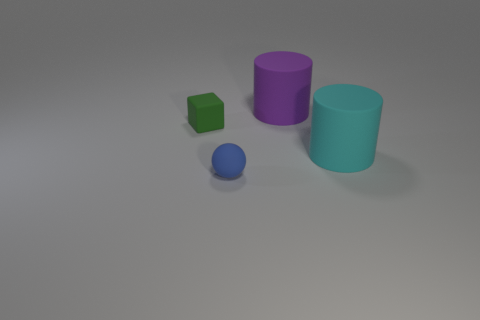There is a large rubber thing that is to the right of the rubber cylinder that is behind the matte cylinder that is on the right side of the purple thing; what is its shape?
Make the answer very short. Cylinder. There is a large matte cylinder in front of the big purple rubber object; is it the same color as the large rubber object on the left side of the big cyan cylinder?
Give a very brief answer. No. Are there any other things that are the same size as the blue matte sphere?
Your response must be concise. Yes. Are there any balls in front of the tiny sphere?
Provide a succinct answer. No. What number of cyan matte things are the same shape as the green matte thing?
Offer a very short reply. 0. What is the color of the big cylinder behind the small green thing that is left of the large matte cylinder in front of the tiny rubber block?
Give a very brief answer. Purple. Are the tiny thing that is in front of the green matte thing and the small thing that is on the left side of the small blue rubber ball made of the same material?
Your answer should be compact. Yes. How many objects are tiny rubber objects behind the matte ball or small red shiny spheres?
Your answer should be very brief. 1. How many objects are blocks or green matte things that are in front of the large purple matte cylinder?
Give a very brief answer. 1. What number of other blocks are the same size as the green rubber block?
Provide a short and direct response. 0. 